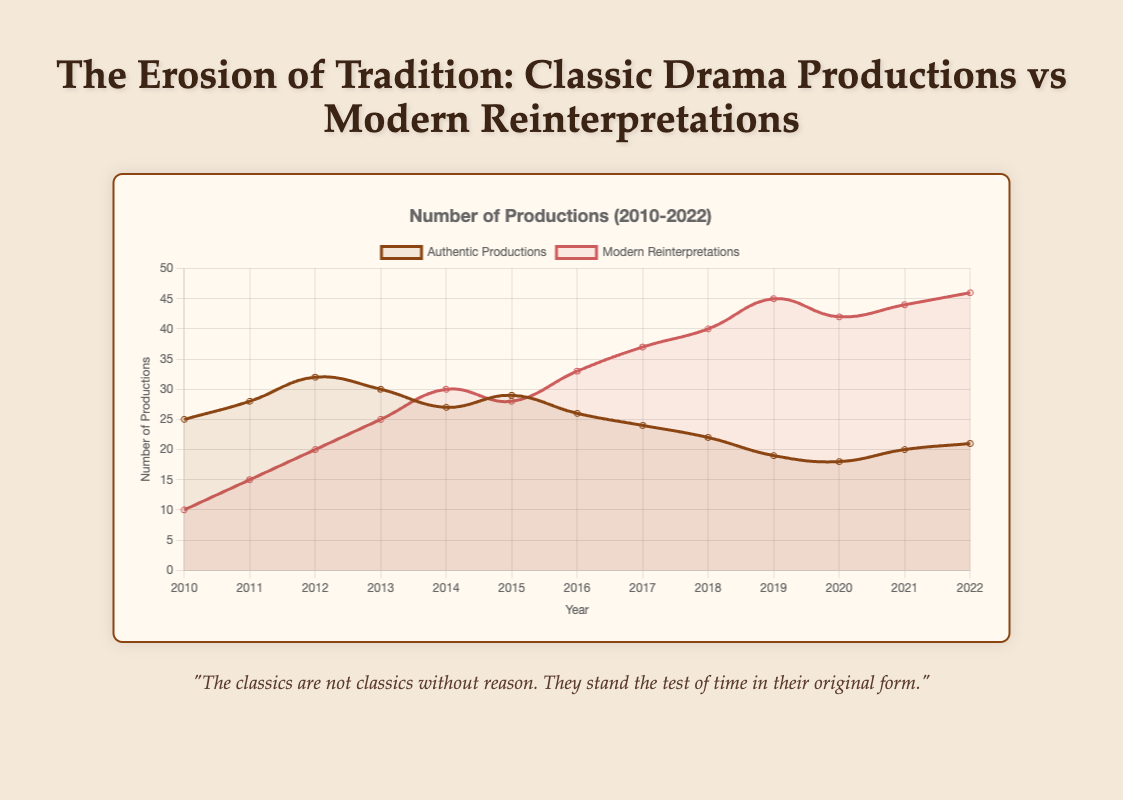How did the number of authentic productions change from 2010 to 2022? From 2010 to 2022, the number of authentic productions decreased from 25 to 21. This can be seen by comparing the value in 2010 with the value in 2022 on the chart.
Answer: Decreased by 4 Which year saw the highest number of modern reinterpretations? By looking at the curve for modern reinterpretations, we see that 2022 had the highest number of reinterpretations with 46 productions.
Answer: 2022 What is the difference between authentic productions and modern reinterpretations in 2018? In 2018, authentic productions were 22, and modern reinterpretations were 40. The difference is 40 - 22.
Answer: 18 How many years had more than 30 modern reinterpretations? From the chart, the years that had more than 30 modern reinterpretations are 2014, 2016, 2017, 2018, 2019, 2020, 2021, and 2022, which is 8 years.
Answer: 8 What is the sum of authentic productions and modern reinterpretations in 2015? In 2015, the number of authentic productions was 29, and modern reinterpretations were 28. The sum is 29 + 28.
Answer: 57 In which years were the numbers of authentic productions approximately the same? From the chart, the number of authentic productions was approximately the same in 2010 (25) and 2017 (24) with only a 1 production difference.
Answer: 2010 and 2017 What is the average number of modern reinterpretations between 2010 and 2015? Sum up the numbers of modern reinterpretations from 2010 to 2015 (10 + 15 + 20 + 25 + 30 + 28 = 128) and divide by 6. The average is 128 / 6.
Answer: 21.33 Which type of production had more years of increasing trends, authentic productions or modern reinterpretations? Modern reinterpretations had more increasing trend years. Modern reinterpretations increased from 2010 to 2019. Authentic productions only showed an increasing trend between 2010 and 2012, then fluctuated.
Answer: Modern reinterpretations In what year did the number of modern reinterpretations surpass the number of authentic productions? By looking at the chart, modern reinterpretations surpassed authentic productions in 2014.
Answer: 2014 Which curve (authentic productions or modern reinterpretations) shows a more consistent trend over the years? Modern reinterpretations show a more consistent upward trend, whereas authentic productions fluctuate more significantly.
Answer: Modern reinterpretations 